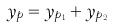Convert formula to latex. <formula><loc_0><loc_0><loc_500><loc_500>y _ { p } = y _ { p _ { 1 } } + y _ { p _ { 2 } }</formula> 